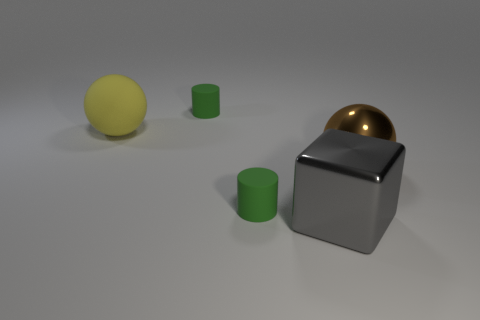Add 5 large gray metal objects. How many objects exist? 10 Subtract all cylinders. How many objects are left? 3 Subtract all matte spheres. Subtract all cylinders. How many objects are left? 2 Add 4 big yellow rubber things. How many big yellow rubber things are left? 5 Add 3 yellow objects. How many yellow objects exist? 4 Subtract 0 blue cylinders. How many objects are left? 5 